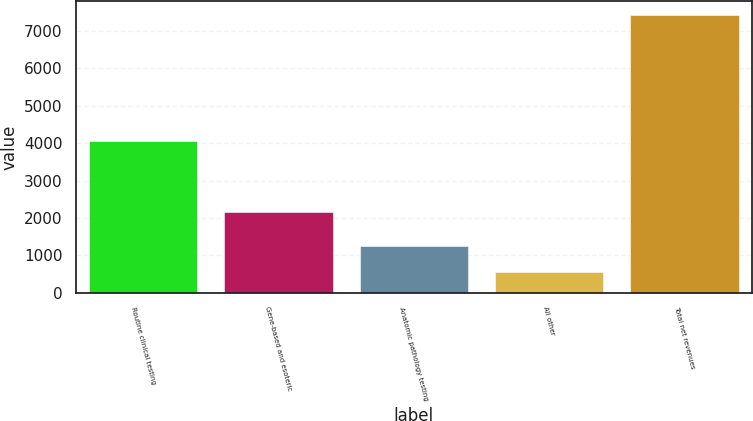Convert chart to OTSL. <chart><loc_0><loc_0><loc_500><loc_500><bar_chart><fcel>Routine clinical testing<fcel>Gene-based and esoteric<fcel>Anatomic pathology testing<fcel>All other<fcel>Total net revenues<nl><fcel>4066<fcel>2158<fcel>1249.3<fcel>562<fcel>7435<nl></chart> 